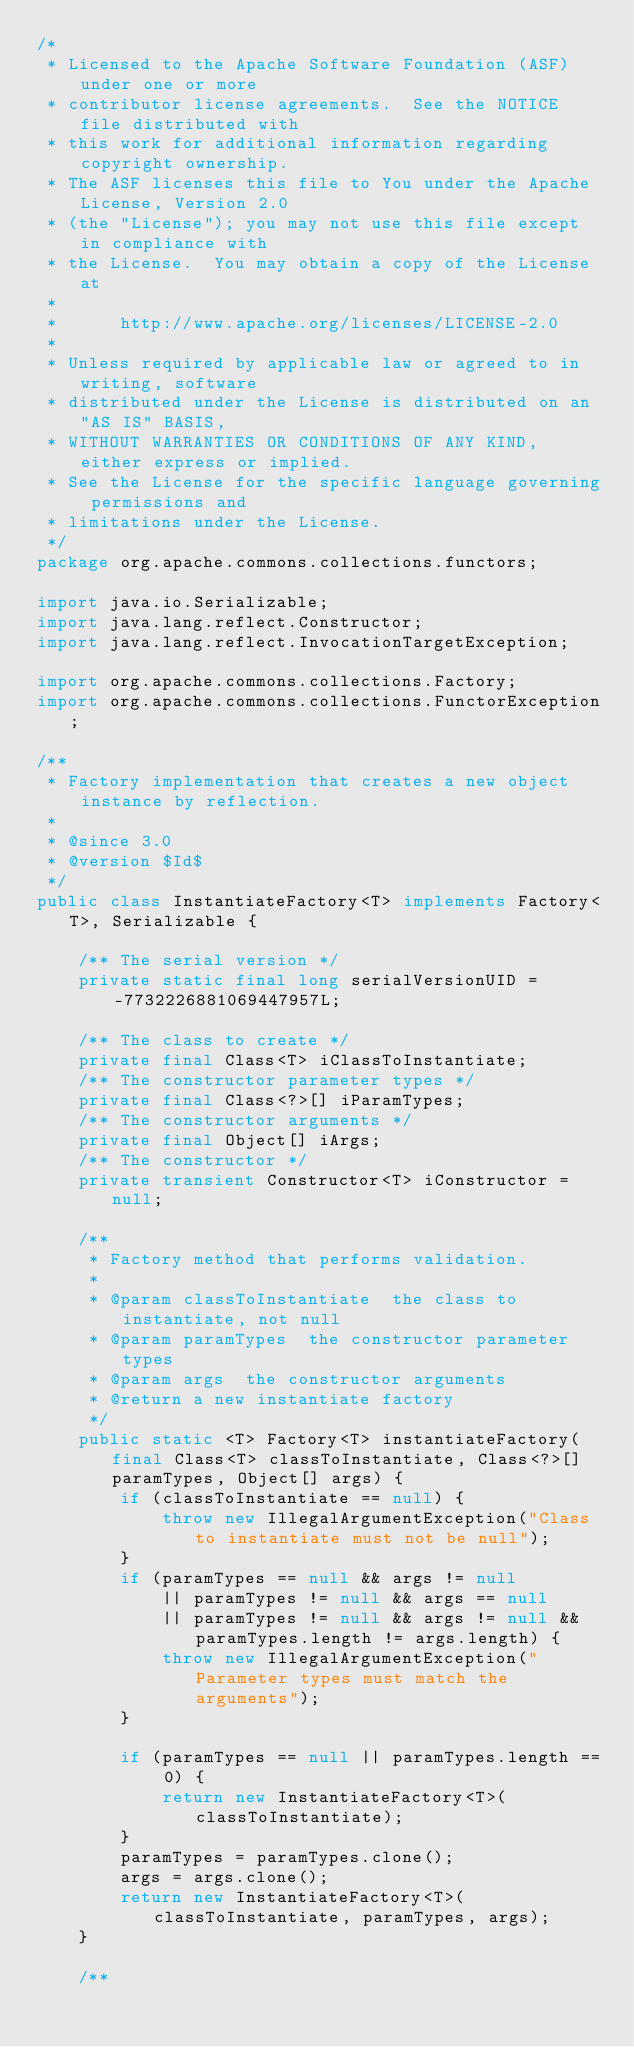Convert code to text. <code><loc_0><loc_0><loc_500><loc_500><_Java_>/*
 * Licensed to the Apache Software Foundation (ASF) under one or more
 * contributor license agreements.  See the NOTICE file distributed with
 * this work for additional information regarding copyright ownership.
 * The ASF licenses this file to You under the Apache License, Version 2.0
 * (the "License"); you may not use this file except in compliance with
 * the License.  You may obtain a copy of the License at
 *
 *      http://www.apache.org/licenses/LICENSE-2.0
 *
 * Unless required by applicable law or agreed to in writing, software
 * distributed under the License is distributed on an "AS IS" BASIS,
 * WITHOUT WARRANTIES OR CONDITIONS OF ANY KIND, either express or implied.
 * See the License for the specific language governing permissions and
 * limitations under the License.
 */
package org.apache.commons.collections.functors;

import java.io.Serializable;
import java.lang.reflect.Constructor;
import java.lang.reflect.InvocationTargetException;

import org.apache.commons.collections.Factory;
import org.apache.commons.collections.FunctorException;

/**
 * Factory implementation that creates a new object instance by reflection.
 *
 * @since 3.0
 * @version $Id$
 */
public class InstantiateFactory<T> implements Factory<T>, Serializable {

    /** The serial version */
    private static final long serialVersionUID = -7732226881069447957L;

    /** The class to create */
    private final Class<T> iClassToInstantiate;
    /** The constructor parameter types */
    private final Class<?>[] iParamTypes;
    /** The constructor arguments */
    private final Object[] iArgs;
    /** The constructor */
    private transient Constructor<T> iConstructor = null;

    /**
     * Factory method that performs validation.
     * 
     * @param classToInstantiate  the class to instantiate, not null
     * @param paramTypes  the constructor parameter types
     * @param args  the constructor arguments
     * @return a new instantiate factory
     */
    public static <T> Factory<T> instantiateFactory(final Class<T> classToInstantiate, Class<?>[] paramTypes, Object[] args) {
        if (classToInstantiate == null) {
            throw new IllegalArgumentException("Class to instantiate must not be null");
        }
        if (paramTypes == null && args != null
            || paramTypes != null && args == null
            || paramTypes != null && args != null && paramTypes.length != args.length) {
            throw new IllegalArgumentException("Parameter types must match the arguments");
        }

        if (paramTypes == null || paramTypes.length == 0) {
            return new InstantiateFactory<T>(classToInstantiate);
        }
        paramTypes = paramTypes.clone();
        args = args.clone();
        return new InstantiateFactory<T>(classToInstantiate, paramTypes, args);
    }

    /**</code> 